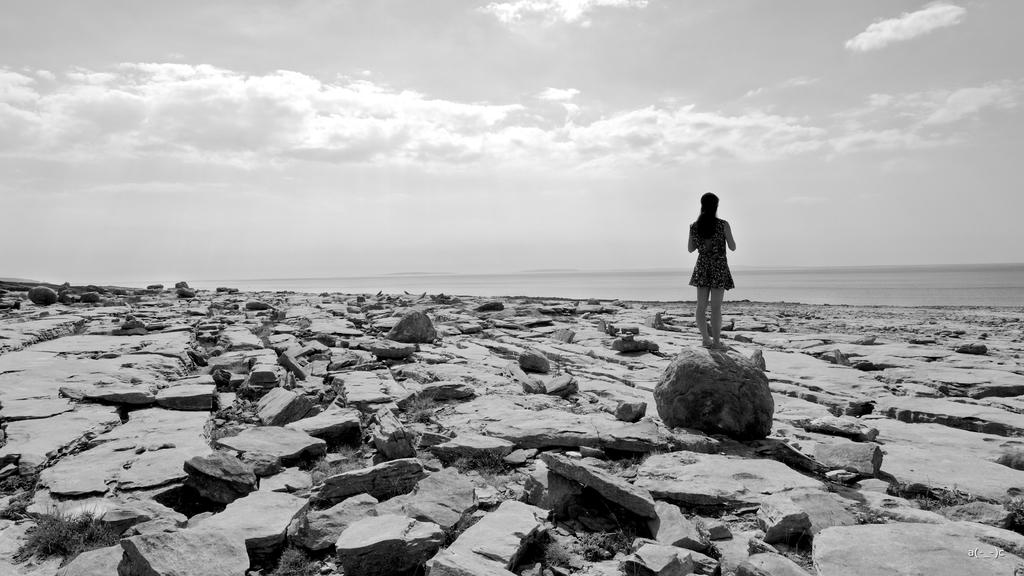What type of surface is visible in the image? There is a surface with many rocks in the image. Who is present on the surface in the image? A woman is standing on the surface. What else can be seen in the image besides the surface and the woman? There is a water surface and the sky visible in the image. What is the condition of the sky in the image? Clouds are present in the sky. What type of yak can be seen grazing near the woman in the image? There is no yak present in the image; it only features a surface with rocks, a woman, a water surface, and the sky with clouds. 